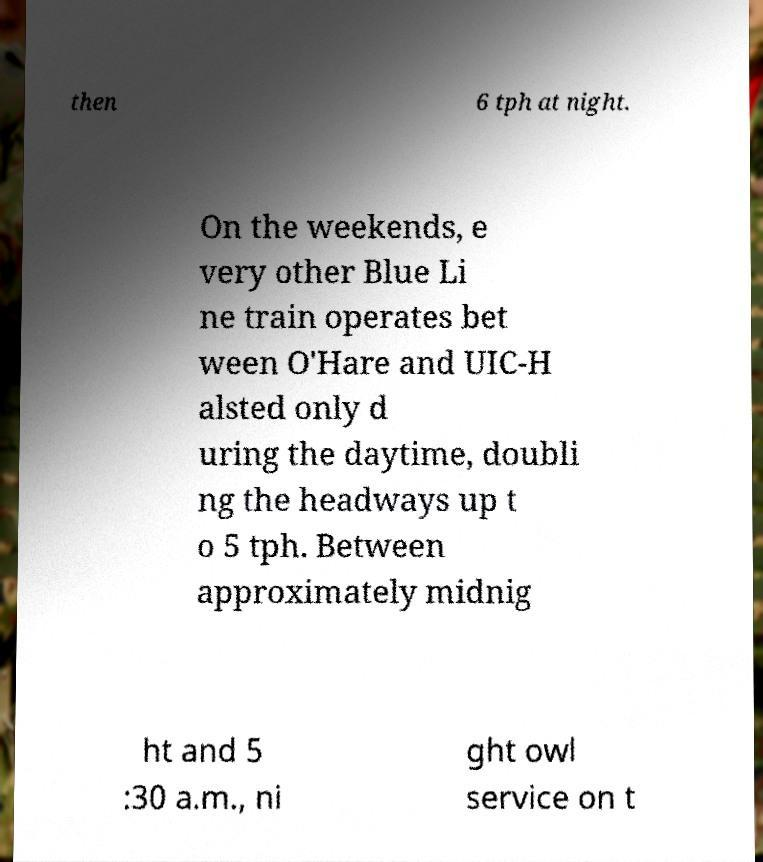Please identify and transcribe the text found in this image. then 6 tph at night. On the weekends, e very other Blue Li ne train operates bet ween O'Hare and UIC-H alsted only d uring the daytime, doubli ng the headways up t o 5 tph. Between approximately midnig ht and 5 :30 a.m., ni ght owl service on t 